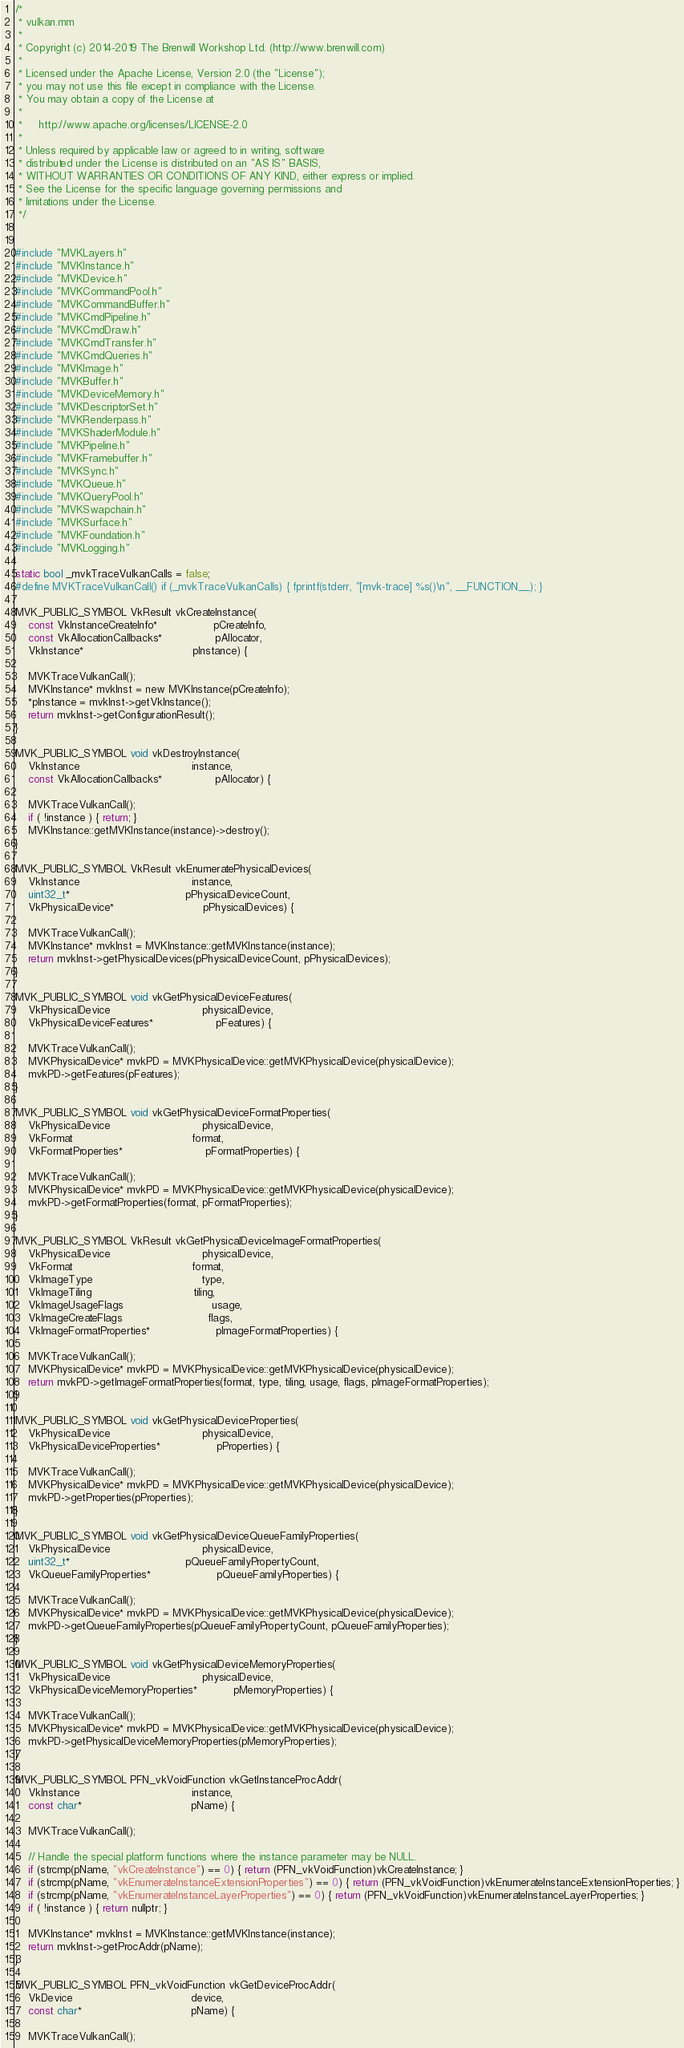Convert code to text. <code><loc_0><loc_0><loc_500><loc_500><_ObjectiveC_>/*
 * vulkan.mm
 *
 * Copyright (c) 2014-2019 The Brenwill Workshop Ltd. (http://www.brenwill.com)
 *
 * Licensed under the Apache License, Version 2.0 (the "License");
 * you may not use this file except in compliance with the License.
 * You may obtain a copy of the License at
 * 
 *     http://www.apache.org/licenses/LICENSE-2.0
 * 
 * Unless required by applicable law or agreed to in writing, software
 * distributed under the License is distributed on an "AS IS" BASIS,
 * WITHOUT WARRANTIES OR CONDITIONS OF ANY KIND, either express or implied.
 * See the License for the specific language governing permissions and
 * limitations under the License.
 */


#include "MVKLayers.h"
#include "MVKInstance.h"
#include "MVKDevice.h"
#include "MVKCommandPool.h"
#include "MVKCommandBuffer.h"
#include "MVKCmdPipeline.h"
#include "MVKCmdDraw.h"
#include "MVKCmdTransfer.h"
#include "MVKCmdQueries.h"
#include "MVKImage.h"
#include "MVKBuffer.h"
#include "MVKDeviceMemory.h"
#include "MVKDescriptorSet.h"
#include "MVKRenderpass.h"
#include "MVKShaderModule.h"
#include "MVKPipeline.h"
#include "MVKFramebuffer.h"
#include "MVKSync.h"
#include "MVKQueue.h"
#include "MVKQueryPool.h"
#include "MVKSwapchain.h"
#include "MVKSurface.h"
#include "MVKFoundation.h"
#include "MVKLogging.h"

static bool _mvkTraceVulkanCalls = false;
#define MVKTraceVulkanCall()	if (_mvkTraceVulkanCalls) { fprintf(stderr, "[mvk-trace] %s()\n", __FUNCTION__); }

MVK_PUBLIC_SYMBOL VkResult vkCreateInstance(
    const VkInstanceCreateInfo*                 pCreateInfo,
	const VkAllocationCallbacks*                pAllocator,
    VkInstance*                                 pInstance) {

	MVKTraceVulkanCall();
	MVKInstance* mvkInst = new MVKInstance(pCreateInfo);
	*pInstance = mvkInst->getVkInstance();
	return mvkInst->getConfigurationResult();
}

MVK_PUBLIC_SYMBOL void vkDestroyInstance(
    VkInstance                                  instance,
	const VkAllocationCallbacks*                pAllocator) {

	MVKTraceVulkanCall();
	if ( !instance ) { return; }
	MVKInstance::getMVKInstance(instance)->destroy();
}

MVK_PUBLIC_SYMBOL VkResult vkEnumeratePhysicalDevices(
    VkInstance                                  instance,
    uint32_t*                                   pPhysicalDeviceCount,
    VkPhysicalDevice*                           pPhysicalDevices) {

	MVKTraceVulkanCall();
	MVKInstance* mvkInst = MVKInstance::getMVKInstance(instance);
	return mvkInst->getPhysicalDevices(pPhysicalDeviceCount, pPhysicalDevices);
}

MVK_PUBLIC_SYMBOL void vkGetPhysicalDeviceFeatures(
    VkPhysicalDevice                            physicalDevice,
    VkPhysicalDeviceFeatures*                   pFeatures) {
	
	MVKTraceVulkanCall();
	MVKPhysicalDevice* mvkPD = MVKPhysicalDevice::getMVKPhysicalDevice(physicalDevice);
	mvkPD->getFeatures(pFeatures);
}

MVK_PUBLIC_SYMBOL void vkGetPhysicalDeviceFormatProperties(
    VkPhysicalDevice                            physicalDevice,
    VkFormat                                    format,
    VkFormatProperties*                         pFormatProperties) {
	
	MVKTraceVulkanCall();
	MVKPhysicalDevice* mvkPD = MVKPhysicalDevice::getMVKPhysicalDevice(physicalDevice);
	mvkPD->getFormatProperties(format, pFormatProperties);
}

MVK_PUBLIC_SYMBOL VkResult vkGetPhysicalDeviceImageFormatProperties(
    VkPhysicalDevice                            physicalDevice,
    VkFormat                                    format,
    VkImageType                                 type,
    VkImageTiling                               tiling,
    VkImageUsageFlags                           usage,
    VkImageCreateFlags                          flags,
    VkImageFormatProperties*                    pImageFormatProperties) {
	
	MVKTraceVulkanCall();
    MVKPhysicalDevice* mvkPD = MVKPhysicalDevice::getMVKPhysicalDevice(physicalDevice);
    return mvkPD->getImageFormatProperties(format, type, tiling, usage, flags, pImageFormatProperties);
}

MVK_PUBLIC_SYMBOL void vkGetPhysicalDeviceProperties(
    VkPhysicalDevice                            physicalDevice,
    VkPhysicalDeviceProperties*                 pProperties) {

	MVKTraceVulkanCall();
	MVKPhysicalDevice* mvkPD = MVKPhysicalDevice::getMVKPhysicalDevice(physicalDevice);
	mvkPD->getProperties(pProperties);
}

MVK_PUBLIC_SYMBOL void vkGetPhysicalDeviceQueueFamilyProperties(
	VkPhysicalDevice                            physicalDevice,
	uint32_t*                                   pQueueFamilyPropertyCount,
	VkQueueFamilyProperties*                    pQueueFamilyProperties) {
	
	MVKTraceVulkanCall();
	MVKPhysicalDevice* mvkPD = MVKPhysicalDevice::getMVKPhysicalDevice(physicalDevice);
	mvkPD->getQueueFamilyProperties(pQueueFamilyPropertyCount, pQueueFamilyProperties);
}

MVK_PUBLIC_SYMBOL void vkGetPhysicalDeviceMemoryProperties(
    VkPhysicalDevice                            physicalDevice,
    VkPhysicalDeviceMemoryProperties*           pMemoryProperties) {

	MVKTraceVulkanCall();
	MVKPhysicalDevice* mvkPD = MVKPhysicalDevice::getMVKPhysicalDevice(physicalDevice);
	mvkPD->getPhysicalDeviceMemoryProperties(pMemoryProperties);
}

MVK_PUBLIC_SYMBOL PFN_vkVoidFunction vkGetInstanceProcAddr(
    VkInstance                                  instance,
    const char*                                 pName) {

	MVKTraceVulkanCall();

	// Handle the special platform functions where the instance parameter may be NULL.
	if (strcmp(pName, "vkCreateInstance") == 0) { return (PFN_vkVoidFunction)vkCreateInstance; }
	if (strcmp(pName, "vkEnumerateInstanceExtensionProperties") == 0) { return (PFN_vkVoidFunction)vkEnumerateInstanceExtensionProperties; }
	if (strcmp(pName, "vkEnumerateInstanceLayerProperties") == 0) { return (PFN_vkVoidFunction)vkEnumerateInstanceLayerProperties; }
	if ( !instance ) { return nullptr; }

	MVKInstance* mvkInst = MVKInstance::getMVKInstance(instance);
	return mvkInst->getProcAddr(pName);
}

MVK_PUBLIC_SYMBOL PFN_vkVoidFunction vkGetDeviceProcAddr(
    VkDevice                                    device,
    const char*                                 pName) {
	
	MVKTraceVulkanCall();</code> 